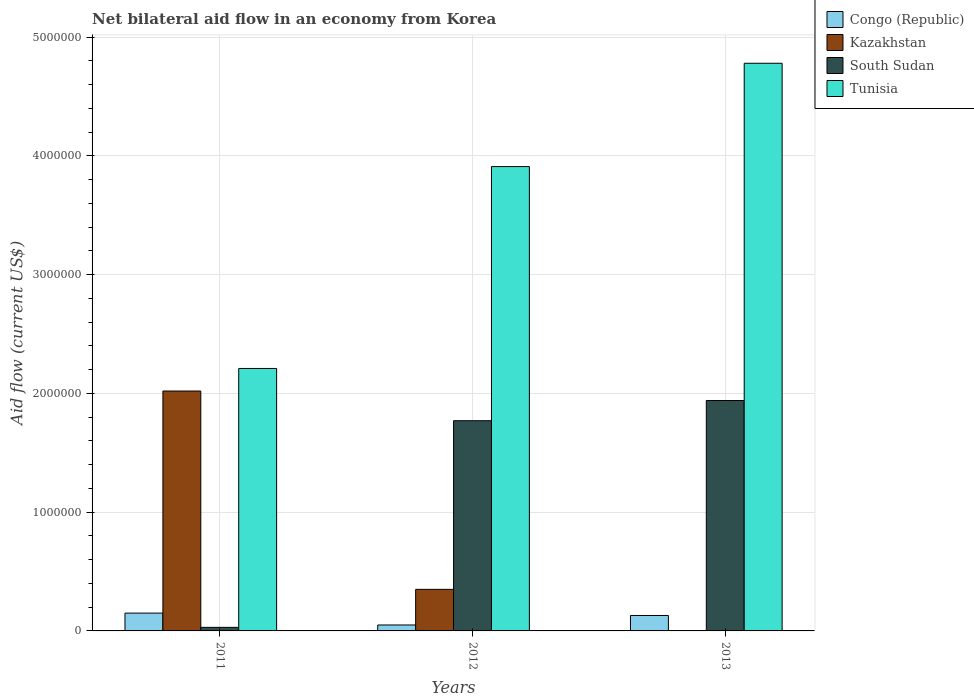How many bars are there on the 3rd tick from the left?
Your answer should be very brief. 3. What is the label of the 2nd group of bars from the left?
Offer a terse response. 2012. In how many cases, is the number of bars for a given year not equal to the number of legend labels?
Keep it short and to the point. 1. What is the net bilateral aid flow in Congo (Republic) in 2013?
Offer a very short reply. 1.30e+05. Across all years, what is the maximum net bilateral aid flow in Kazakhstan?
Your answer should be very brief. 2.02e+06. In which year was the net bilateral aid flow in Tunisia maximum?
Make the answer very short. 2013. What is the total net bilateral aid flow in Tunisia in the graph?
Provide a short and direct response. 1.09e+07. What is the difference between the net bilateral aid flow in Congo (Republic) in 2011 and the net bilateral aid flow in South Sudan in 2013?
Provide a short and direct response. -1.79e+06. What is the average net bilateral aid flow in Kazakhstan per year?
Provide a short and direct response. 7.90e+05. In the year 2012, what is the difference between the net bilateral aid flow in Kazakhstan and net bilateral aid flow in South Sudan?
Make the answer very short. -1.42e+06. What is the ratio of the net bilateral aid flow in Tunisia in 2012 to that in 2013?
Your answer should be very brief. 0.82. What is the difference between the highest and the second highest net bilateral aid flow in Tunisia?
Offer a terse response. 8.70e+05. What is the difference between the highest and the lowest net bilateral aid flow in Kazakhstan?
Provide a short and direct response. 2.02e+06. Is the sum of the net bilateral aid flow in Kazakhstan in 2011 and 2012 greater than the maximum net bilateral aid flow in Tunisia across all years?
Ensure brevity in your answer.  No. Is it the case that in every year, the sum of the net bilateral aid flow in South Sudan and net bilateral aid flow in Congo (Republic) is greater than the net bilateral aid flow in Kazakhstan?
Your response must be concise. No. How many bars are there?
Provide a short and direct response. 11. Are all the bars in the graph horizontal?
Offer a terse response. No. How many years are there in the graph?
Ensure brevity in your answer.  3. Does the graph contain grids?
Offer a very short reply. Yes. Where does the legend appear in the graph?
Ensure brevity in your answer.  Top right. How many legend labels are there?
Offer a very short reply. 4. What is the title of the graph?
Offer a very short reply. Net bilateral aid flow in an economy from Korea. What is the Aid flow (current US$) of Kazakhstan in 2011?
Provide a succinct answer. 2.02e+06. What is the Aid flow (current US$) of South Sudan in 2011?
Your response must be concise. 3.00e+04. What is the Aid flow (current US$) in Tunisia in 2011?
Provide a succinct answer. 2.21e+06. What is the Aid flow (current US$) of South Sudan in 2012?
Give a very brief answer. 1.77e+06. What is the Aid flow (current US$) in Tunisia in 2012?
Your answer should be very brief. 3.91e+06. What is the Aid flow (current US$) in Kazakhstan in 2013?
Ensure brevity in your answer.  0. What is the Aid flow (current US$) of South Sudan in 2013?
Provide a short and direct response. 1.94e+06. What is the Aid flow (current US$) of Tunisia in 2013?
Your response must be concise. 4.78e+06. Across all years, what is the maximum Aid flow (current US$) in Kazakhstan?
Ensure brevity in your answer.  2.02e+06. Across all years, what is the maximum Aid flow (current US$) in South Sudan?
Your response must be concise. 1.94e+06. Across all years, what is the maximum Aid flow (current US$) in Tunisia?
Offer a terse response. 4.78e+06. Across all years, what is the minimum Aid flow (current US$) of Kazakhstan?
Provide a short and direct response. 0. Across all years, what is the minimum Aid flow (current US$) in South Sudan?
Your response must be concise. 3.00e+04. Across all years, what is the minimum Aid flow (current US$) of Tunisia?
Your answer should be compact. 2.21e+06. What is the total Aid flow (current US$) of Congo (Republic) in the graph?
Give a very brief answer. 3.30e+05. What is the total Aid flow (current US$) in Kazakhstan in the graph?
Ensure brevity in your answer.  2.37e+06. What is the total Aid flow (current US$) in South Sudan in the graph?
Offer a very short reply. 3.74e+06. What is the total Aid flow (current US$) of Tunisia in the graph?
Your response must be concise. 1.09e+07. What is the difference between the Aid flow (current US$) in Congo (Republic) in 2011 and that in 2012?
Offer a very short reply. 1.00e+05. What is the difference between the Aid flow (current US$) in Kazakhstan in 2011 and that in 2012?
Provide a short and direct response. 1.67e+06. What is the difference between the Aid flow (current US$) of South Sudan in 2011 and that in 2012?
Your answer should be compact. -1.74e+06. What is the difference between the Aid flow (current US$) of Tunisia in 2011 and that in 2012?
Your answer should be compact. -1.70e+06. What is the difference between the Aid flow (current US$) of South Sudan in 2011 and that in 2013?
Give a very brief answer. -1.91e+06. What is the difference between the Aid flow (current US$) of Tunisia in 2011 and that in 2013?
Make the answer very short. -2.57e+06. What is the difference between the Aid flow (current US$) in Congo (Republic) in 2012 and that in 2013?
Offer a very short reply. -8.00e+04. What is the difference between the Aid flow (current US$) in Tunisia in 2012 and that in 2013?
Make the answer very short. -8.70e+05. What is the difference between the Aid flow (current US$) of Congo (Republic) in 2011 and the Aid flow (current US$) of Kazakhstan in 2012?
Your response must be concise. -2.00e+05. What is the difference between the Aid flow (current US$) in Congo (Republic) in 2011 and the Aid flow (current US$) in South Sudan in 2012?
Make the answer very short. -1.62e+06. What is the difference between the Aid flow (current US$) of Congo (Republic) in 2011 and the Aid flow (current US$) of Tunisia in 2012?
Keep it short and to the point. -3.76e+06. What is the difference between the Aid flow (current US$) of Kazakhstan in 2011 and the Aid flow (current US$) of South Sudan in 2012?
Offer a terse response. 2.50e+05. What is the difference between the Aid flow (current US$) of Kazakhstan in 2011 and the Aid flow (current US$) of Tunisia in 2012?
Offer a terse response. -1.89e+06. What is the difference between the Aid flow (current US$) in South Sudan in 2011 and the Aid flow (current US$) in Tunisia in 2012?
Ensure brevity in your answer.  -3.88e+06. What is the difference between the Aid flow (current US$) in Congo (Republic) in 2011 and the Aid flow (current US$) in South Sudan in 2013?
Keep it short and to the point. -1.79e+06. What is the difference between the Aid flow (current US$) in Congo (Republic) in 2011 and the Aid flow (current US$) in Tunisia in 2013?
Provide a short and direct response. -4.63e+06. What is the difference between the Aid flow (current US$) in Kazakhstan in 2011 and the Aid flow (current US$) in Tunisia in 2013?
Your response must be concise. -2.76e+06. What is the difference between the Aid flow (current US$) in South Sudan in 2011 and the Aid flow (current US$) in Tunisia in 2013?
Provide a succinct answer. -4.75e+06. What is the difference between the Aid flow (current US$) in Congo (Republic) in 2012 and the Aid flow (current US$) in South Sudan in 2013?
Your answer should be very brief. -1.89e+06. What is the difference between the Aid flow (current US$) of Congo (Republic) in 2012 and the Aid flow (current US$) of Tunisia in 2013?
Give a very brief answer. -4.73e+06. What is the difference between the Aid flow (current US$) in Kazakhstan in 2012 and the Aid flow (current US$) in South Sudan in 2013?
Offer a terse response. -1.59e+06. What is the difference between the Aid flow (current US$) in Kazakhstan in 2012 and the Aid flow (current US$) in Tunisia in 2013?
Your response must be concise. -4.43e+06. What is the difference between the Aid flow (current US$) of South Sudan in 2012 and the Aid flow (current US$) of Tunisia in 2013?
Ensure brevity in your answer.  -3.01e+06. What is the average Aid flow (current US$) in Kazakhstan per year?
Provide a succinct answer. 7.90e+05. What is the average Aid flow (current US$) in South Sudan per year?
Offer a terse response. 1.25e+06. What is the average Aid flow (current US$) of Tunisia per year?
Make the answer very short. 3.63e+06. In the year 2011, what is the difference between the Aid flow (current US$) in Congo (Republic) and Aid flow (current US$) in Kazakhstan?
Your response must be concise. -1.87e+06. In the year 2011, what is the difference between the Aid flow (current US$) of Congo (Republic) and Aid flow (current US$) of South Sudan?
Offer a terse response. 1.20e+05. In the year 2011, what is the difference between the Aid flow (current US$) in Congo (Republic) and Aid flow (current US$) in Tunisia?
Offer a terse response. -2.06e+06. In the year 2011, what is the difference between the Aid flow (current US$) in Kazakhstan and Aid flow (current US$) in South Sudan?
Offer a very short reply. 1.99e+06. In the year 2011, what is the difference between the Aid flow (current US$) of South Sudan and Aid flow (current US$) of Tunisia?
Provide a short and direct response. -2.18e+06. In the year 2012, what is the difference between the Aid flow (current US$) of Congo (Republic) and Aid flow (current US$) of Kazakhstan?
Provide a succinct answer. -3.00e+05. In the year 2012, what is the difference between the Aid flow (current US$) in Congo (Republic) and Aid flow (current US$) in South Sudan?
Give a very brief answer. -1.72e+06. In the year 2012, what is the difference between the Aid flow (current US$) of Congo (Republic) and Aid flow (current US$) of Tunisia?
Keep it short and to the point. -3.86e+06. In the year 2012, what is the difference between the Aid flow (current US$) in Kazakhstan and Aid flow (current US$) in South Sudan?
Ensure brevity in your answer.  -1.42e+06. In the year 2012, what is the difference between the Aid flow (current US$) in Kazakhstan and Aid flow (current US$) in Tunisia?
Offer a terse response. -3.56e+06. In the year 2012, what is the difference between the Aid flow (current US$) of South Sudan and Aid flow (current US$) of Tunisia?
Offer a very short reply. -2.14e+06. In the year 2013, what is the difference between the Aid flow (current US$) in Congo (Republic) and Aid flow (current US$) in South Sudan?
Provide a short and direct response. -1.81e+06. In the year 2013, what is the difference between the Aid flow (current US$) in Congo (Republic) and Aid flow (current US$) in Tunisia?
Give a very brief answer. -4.65e+06. In the year 2013, what is the difference between the Aid flow (current US$) in South Sudan and Aid flow (current US$) in Tunisia?
Make the answer very short. -2.84e+06. What is the ratio of the Aid flow (current US$) of Congo (Republic) in 2011 to that in 2012?
Offer a terse response. 3. What is the ratio of the Aid flow (current US$) of Kazakhstan in 2011 to that in 2012?
Your answer should be compact. 5.77. What is the ratio of the Aid flow (current US$) in South Sudan in 2011 to that in 2012?
Your answer should be compact. 0.02. What is the ratio of the Aid flow (current US$) of Tunisia in 2011 to that in 2012?
Provide a short and direct response. 0.57. What is the ratio of the Aid flow (current US$) of Congo (Republic) in 2011 to that in 2013?
Provide a succinct answer. 1.15. What is the ratio of the Aid flow (current US$) in South Sudan in 2011 to that in 2013?
Give a very brief answer. 0.02. What is the ratio of the Aid flow (current US$) in Tunisia in 2011 to that in 2013?
Offer a terse response. 0.46. What is the ratio of the Aid flow (current US$) of Congo (Republic) in 2012 to that in 2013?
Ensure brevity in your answer.  0.38. What is the ratio of the Aid flow (current US$) of South Sudan in 2012 to that in 2013?
Make the answer very short. 0.91. What is the ratio of the Aid flow (current US$) in Tunisia in 2012 to that in 2013?
Give a very brief answer. 0.82. What is the difference between the highest and the second highest Aid flow (current US$) in Congo (Republic)?
Your answer should be very brief. 2.00e+04. What is the difference between the highest and the second highest Aid flow (current US$) of South Sudan?
Provide a short and direct response. 1.70e+05. What is the difference between the highest and the second highest Aid flow (current US$) in Tunisia?
Provide a succinct answer. 8.70e+05. What is the difference between the highest and the lowest Aid flow (current US$) in Kazakhstan?
Keep it short and to the point. 2.02e+06. What is the difference between the highest and the lowest Aid flow (current US$) of South Sudan?
Keep it short and to the point. 1.91e+06. What is the difference between the highest and the lowest Aid flow (current US$) of Tunisia?
Provide a succinct answer. 2.57e+06. 